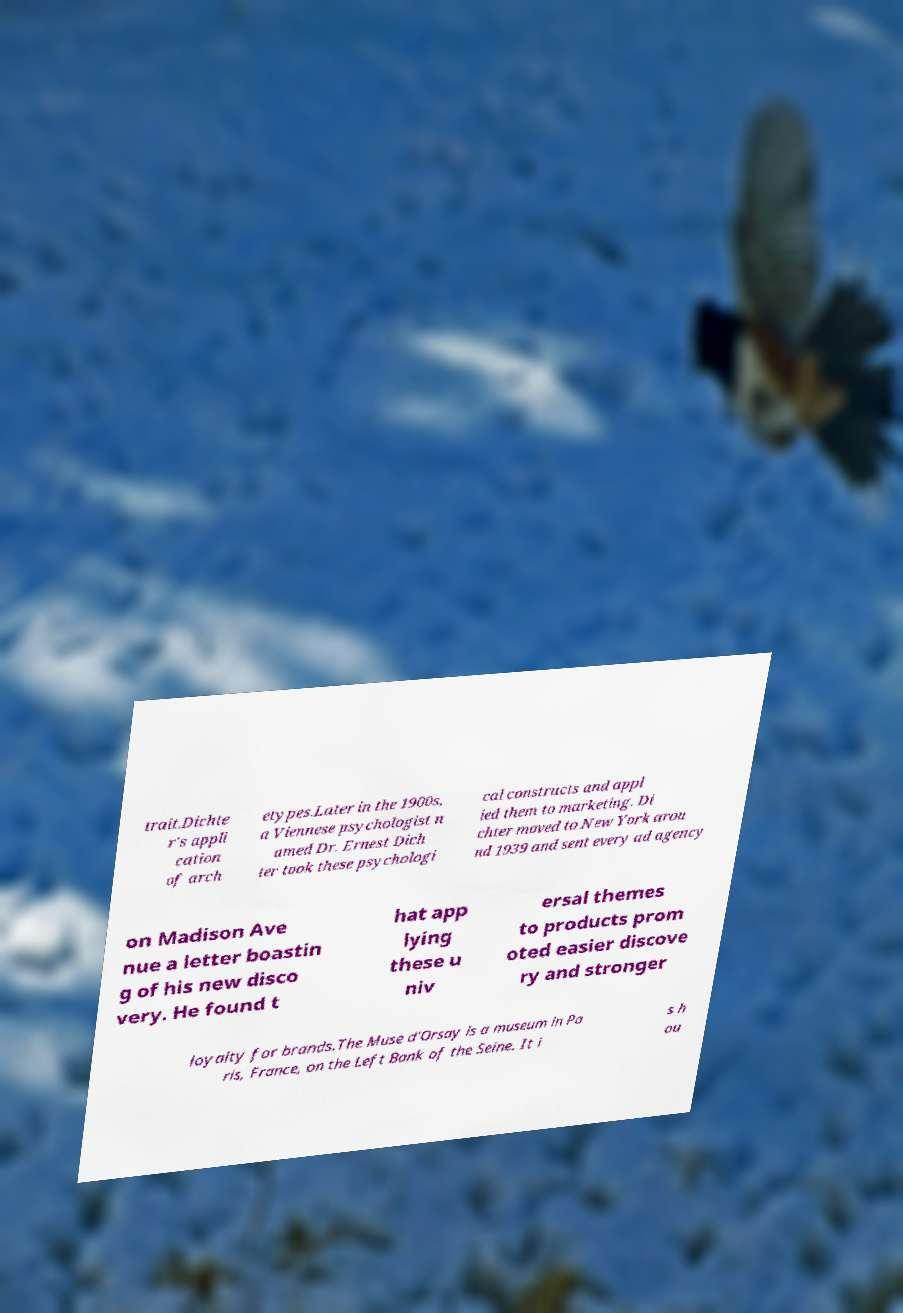For documentation purposes, I need the text within this image transcribed. Could you provide that? trait.Dichte r's appli cation of arch etypes.Later in the 1900s, a Viennese psychologist n amed Dr. Ernest Dich ter took these psychologi cal constructs and appl ied them to marketing. Di chter moved to New York arou nd 1939 and sent every ad agency on Madison Ave nue a letter boastin g of his new disco very. He found t hat app lying these u niv ersal themes to products prom oted easier discove ry and stronger loyalty for brands.The Muse d'Orsay is a museum in Pa ris, France, on the Left Bank of the Seine. It i s h ou 